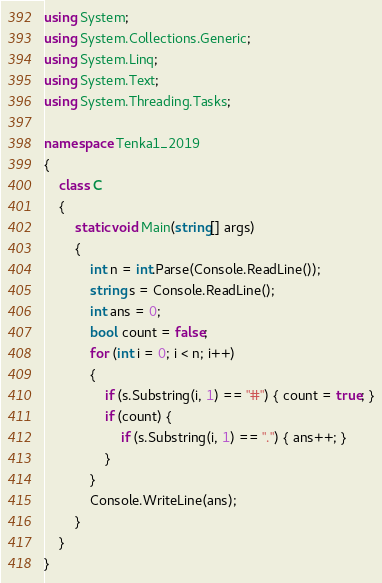Convert code to text. <code><loc_0><loc_0><loc_500><loc_500><_C#_>using System;
using System.Collections.Generic;
using System.Linq;
using System.Text;
using System.Threading.Tasks;

namespace Tenka1_2019
{
    class C
    {
        static void Main(string[] args)
        {
            int n = int.Parse(Console.ReadLine());
            string s = Console.ReadLine();
            int ans = 0;
            bool count = false;
            for (int i = 0; i < n; i++)
            {
                if (s.Substring(i, 1) == "#") { count = true; }
                if (count) {
                    if (s.Substring(i, 1) == ".") { ans++; }
                }
            }
            Console.WriteLine(ans);
        }
    }
}
</code> 